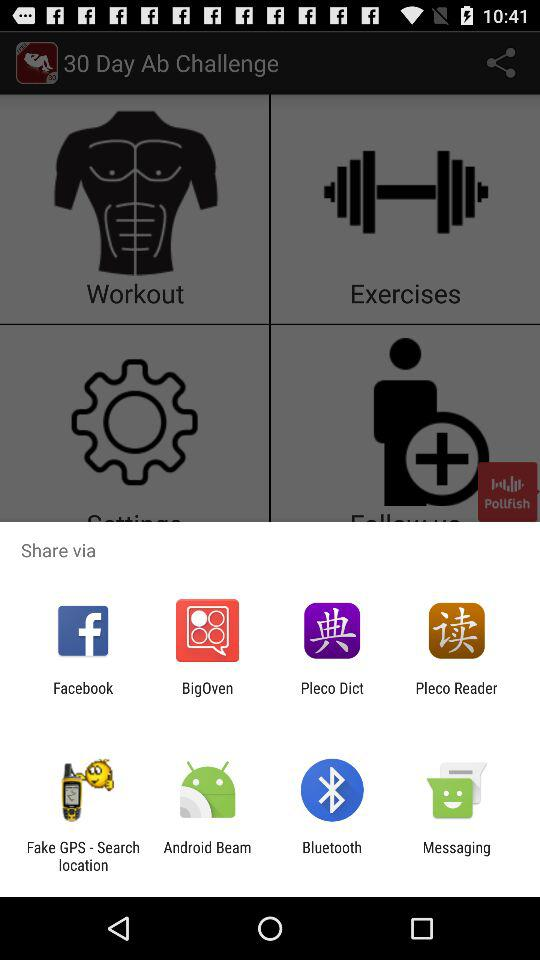Through which application can we share? You can share through "Facebook", "BigOven", "Pleco Dict", "Pleco Reader", "Fake GPS - Search location", "Android Beam", "Bluetooth" and "Messaging". 